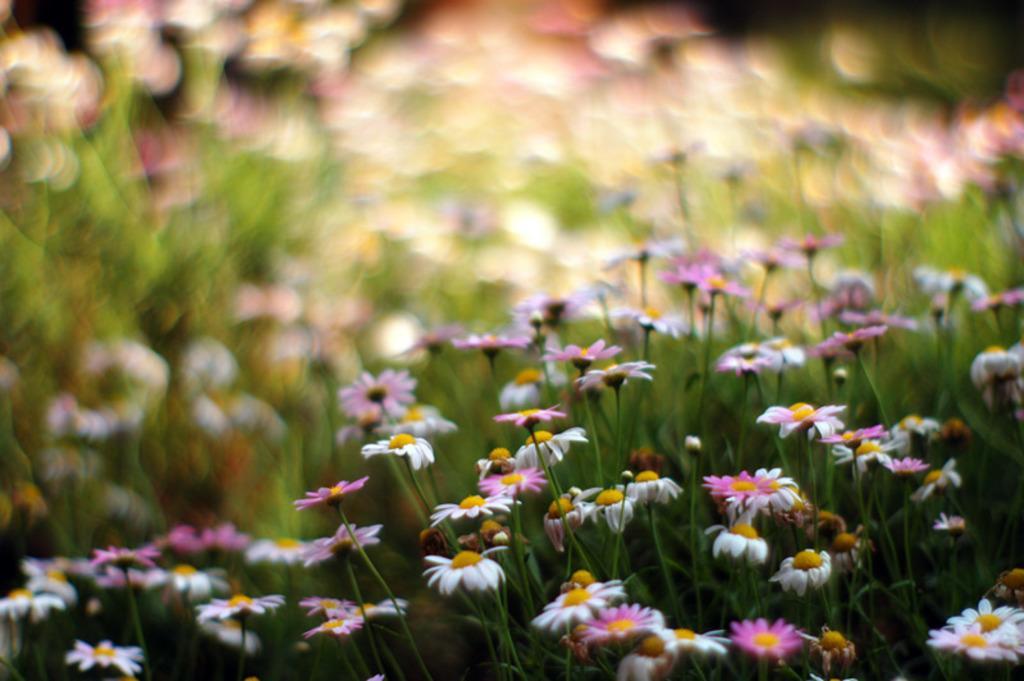Could you give a brief overview of what you see in this image? In this picture, we see flowers and these flowers are in white and pink color. In the background, it is in green, white and pink color. This picture is blurred in the background. 